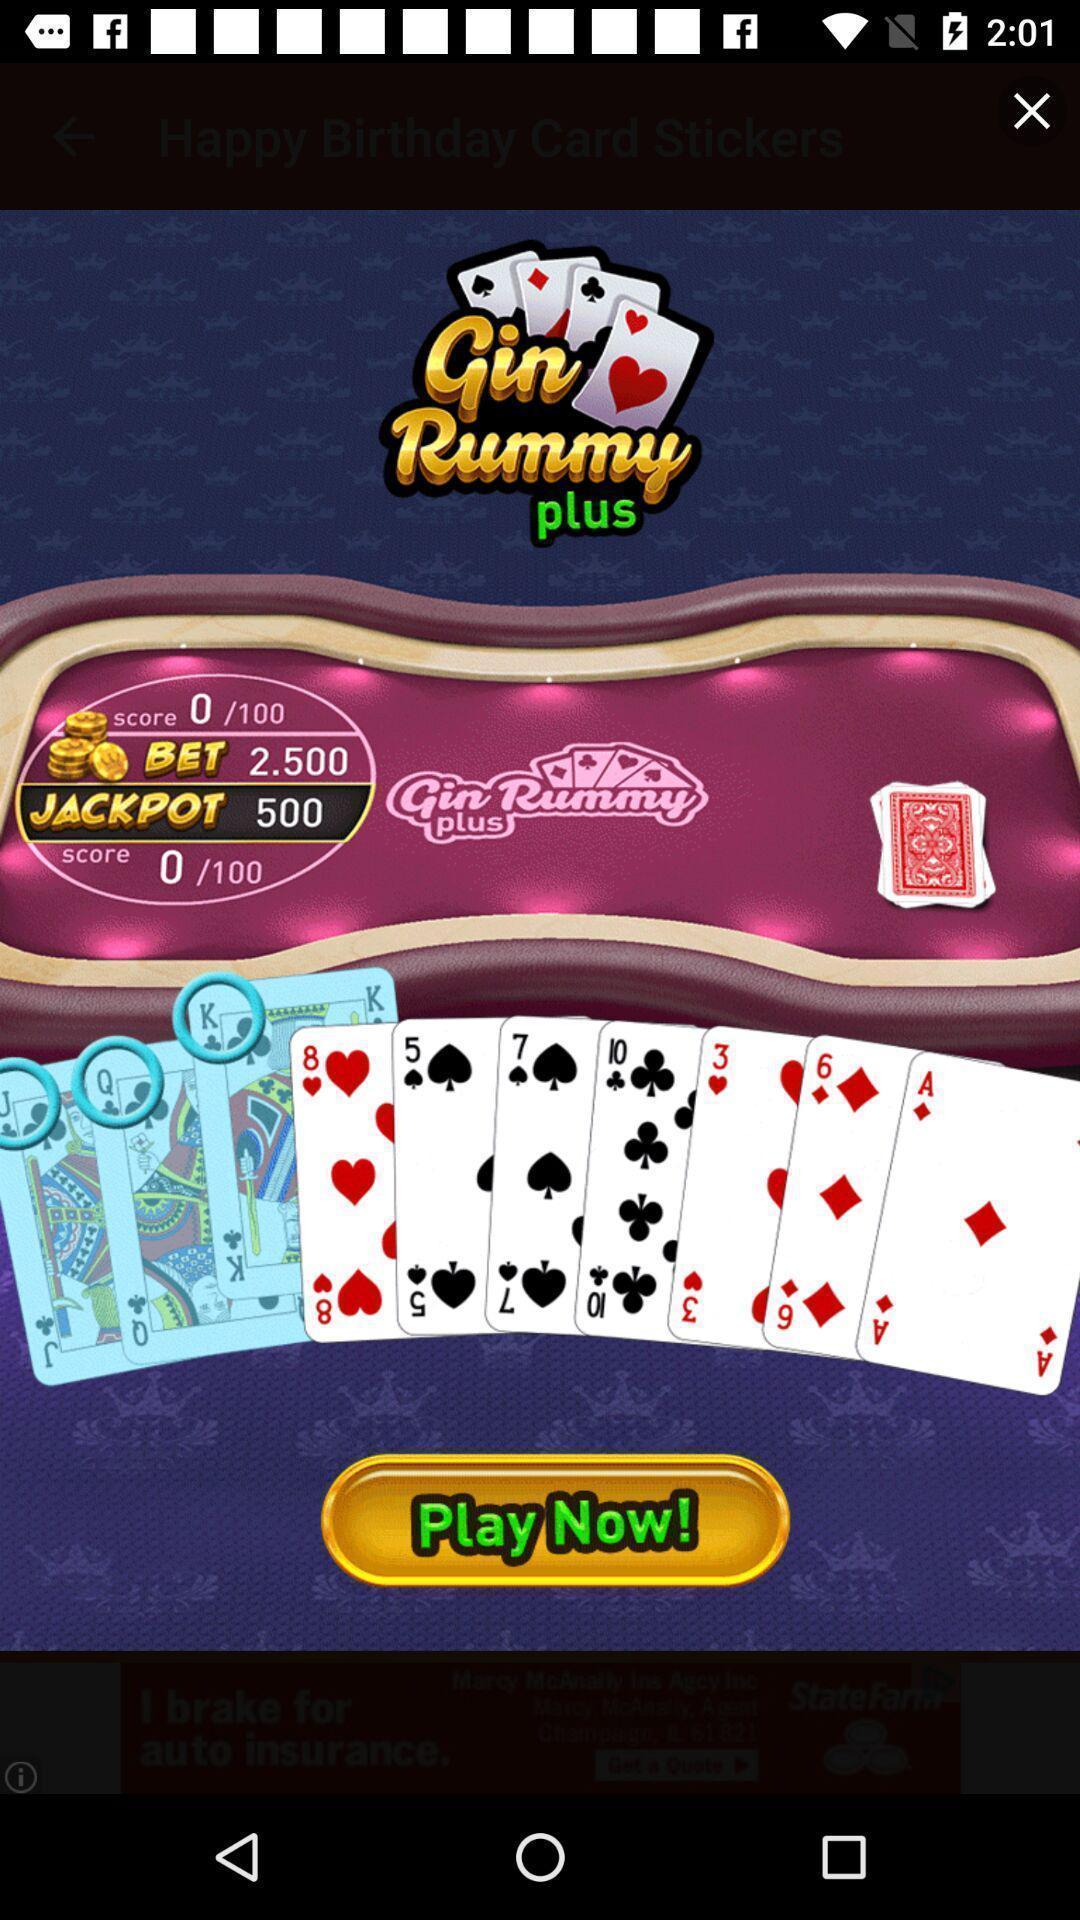Describe this image in words. Pop up advertisement page displayed of a gaming app. 